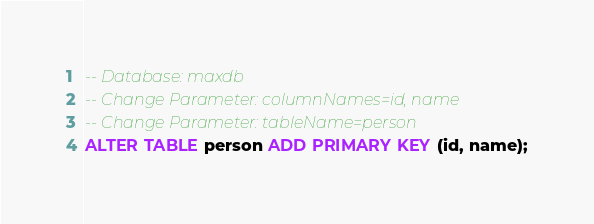Convert code to text. <code><loc_0><loc_0><loc_500><loc_500><_SQL_>-- Database: maxdb
-- Change Parameter: columnNames=id, name
-- Change Parameter: tableName=person
ALTER TABLE person ADD PRIMARY KEY (id, name);
</code> 